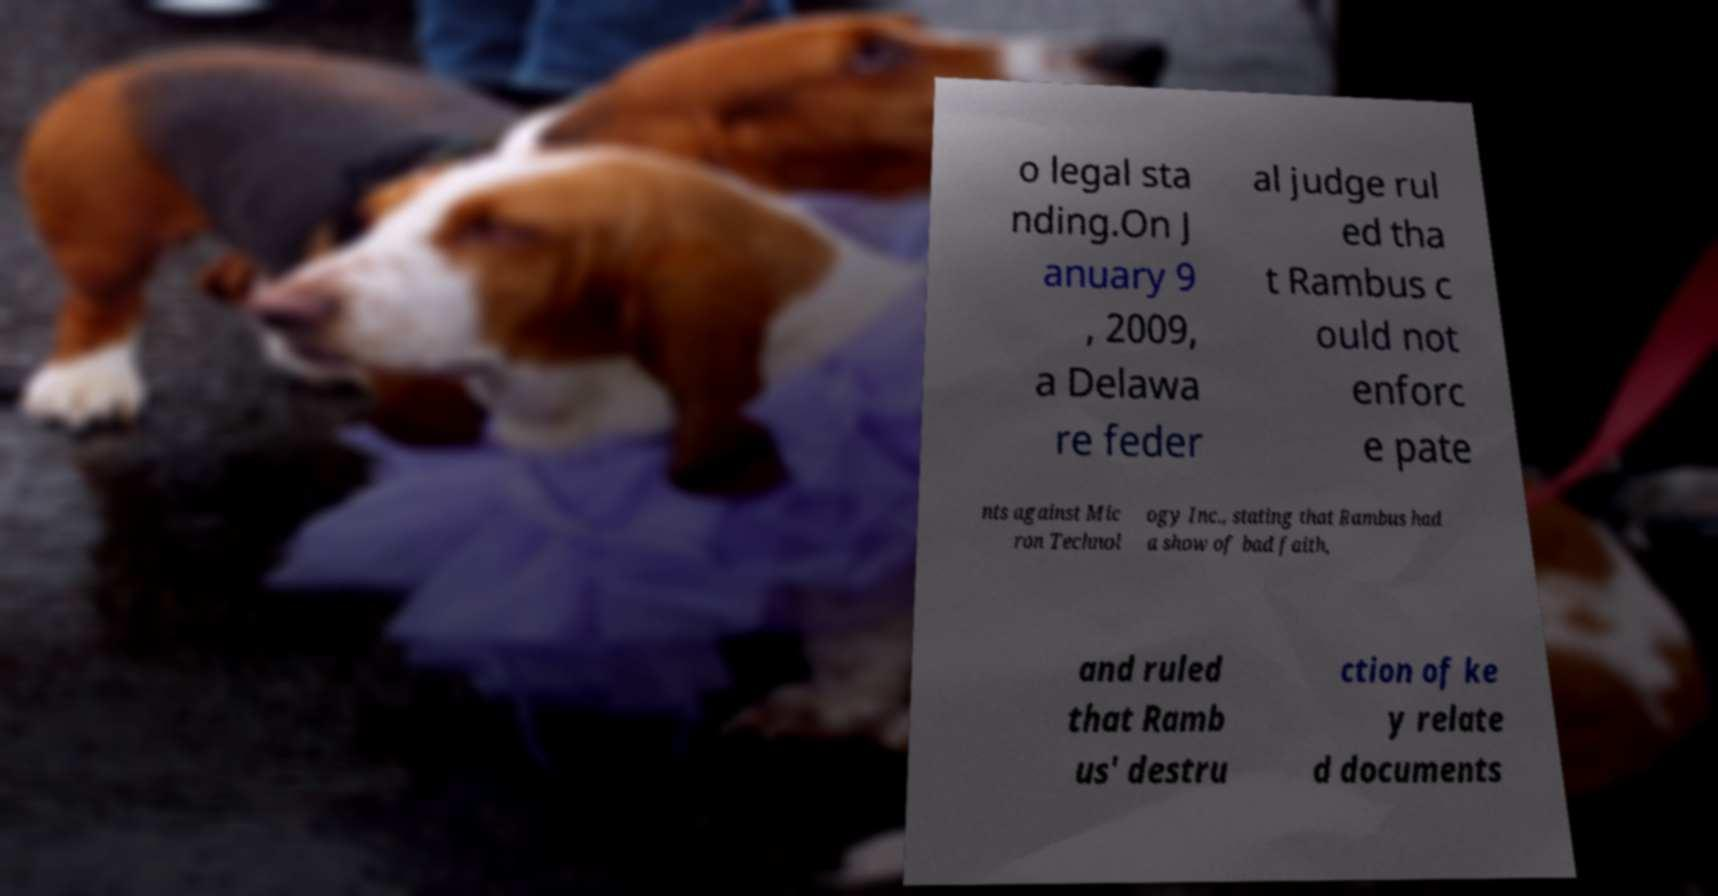For documentation purposes, I need the text within this image transcribed. Could you provide that? o legal sta nding.On J anuary 9 , 2009, a Delawa re feder al judge rul ed tha t Rambus c ould not enforc e pate nts against Mic ron Technol ogy Inc., stating that Rambus had a show of bad faith, and ruled that Ramb us' destru ction of ke y relate d documents 